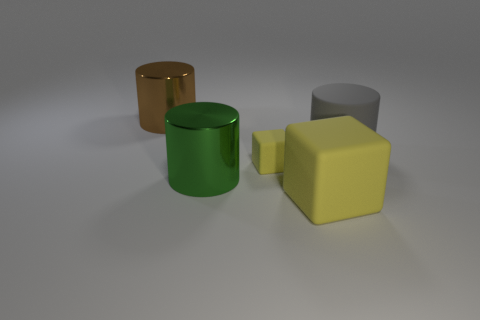Subtract all shiny cylinders. How many cylinders are left? 1 Add 2 large yellow matte cylinders. How many objects exist? 7 Subtract 1 cylinders. How many cylinders are left? 2 Subtract all red cubes. Subtract all cyan cylinders. How many cubes are left? 2 Subtract all brown cubes. How many gray cylinders are left? 1 Subtract all large blue metallic cylinders. Subtract all large yellow matte cubes. How many objects are left? 4 Add 2 large brown metallic things. How many large brown metallic things are left? 3 Add 4 purple rubber cubes. How many purple rubber cubes exist? 4 Subtract all gray cylinders. How many cylinders are left? 2 Subtract 0 green cubes. How many objects are left? 5 